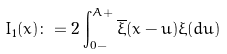Convert formula to latex. <formula><loc_0><loc_0><loc_500><loc_500>I _ { 1 } ( x ) \colon = 2 \int _ { 0 - } ^ { A + } \overline { \xi } ( x - u ) \xi ( d u )</formula> 